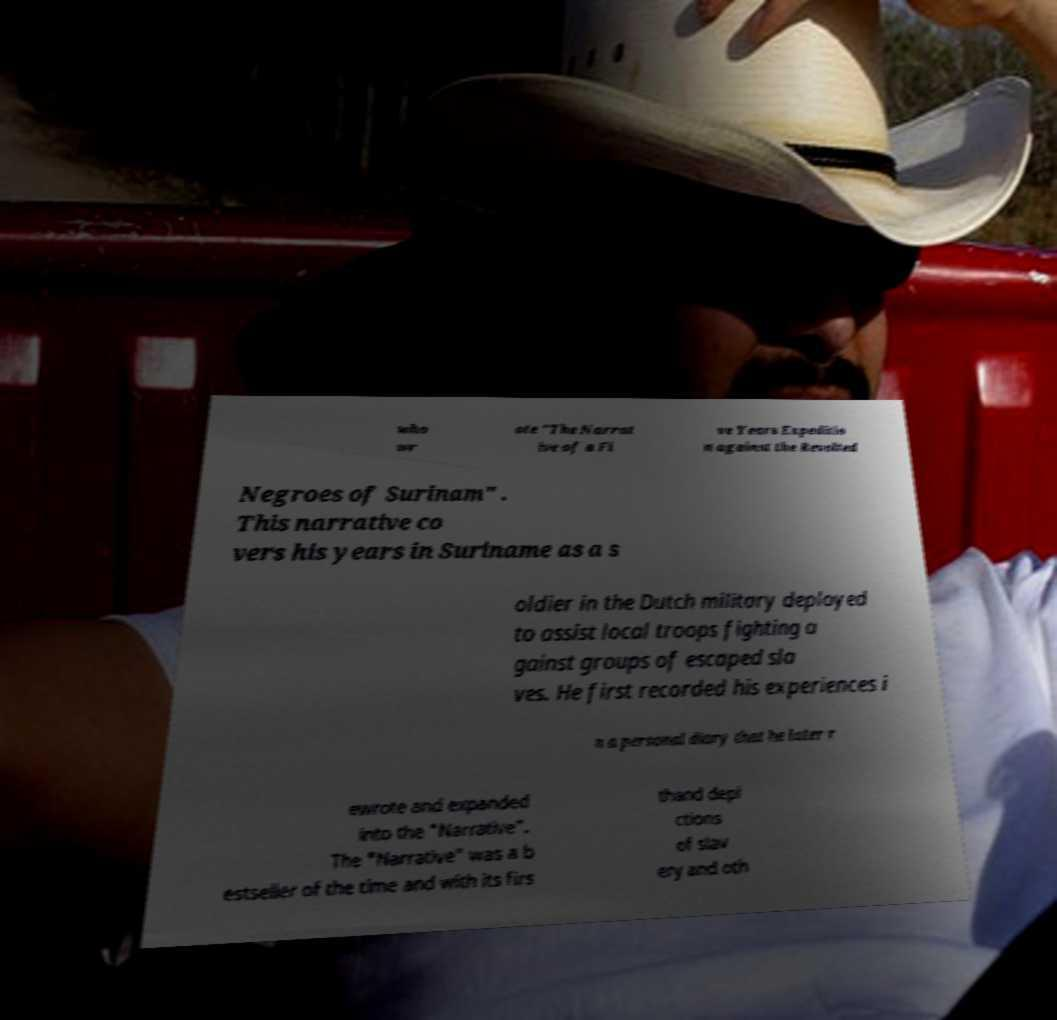Please identify and transcribe the text found in this image. who wr ote "The Narrat ive of a Fi ve Years Expeditio n against the Revolted Negroes of Surinam" . This narrative co vers his years in Suriname as a s oldier in the Dutch military deployed to assist local troops fighting a gainst groups of escaped sla ves. He first recorded his experiences i n a personal diary that he later r ewrote and expanded into the "Narrative". The "Narrative" was a b estseller of the time and with its firs thand depi ctions of slav ery and oth 